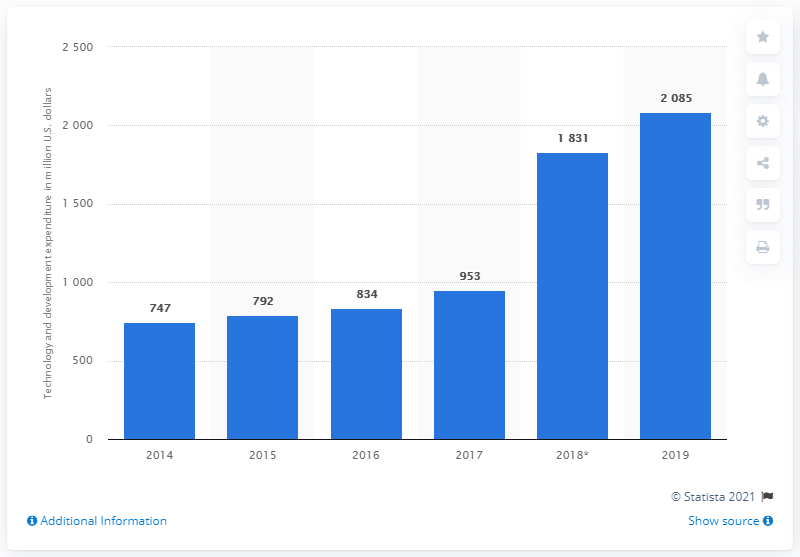Highlight a few significant elements in this photo. PayPal's expenditure on technology and development in the last reported year was 2085. 